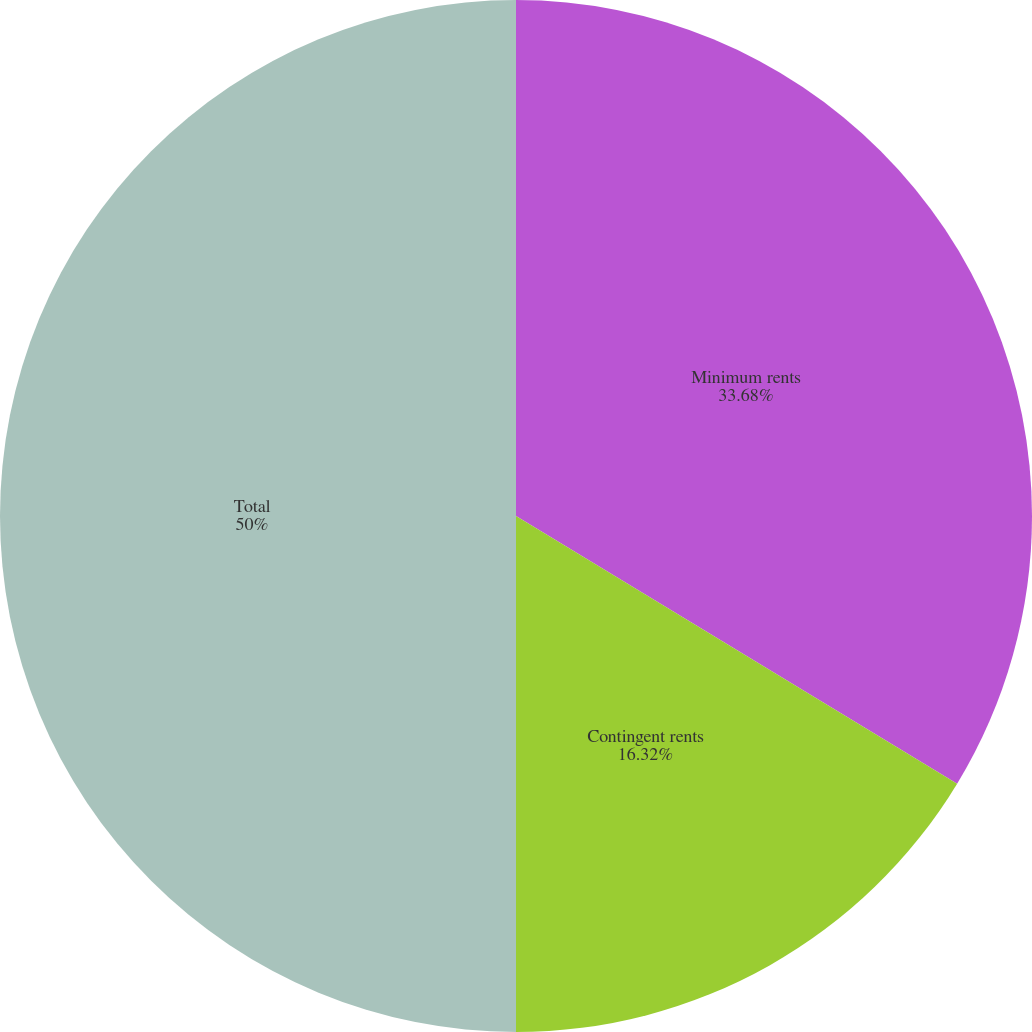Convert chart. <chart><loc_0><loc_0><loc_500><loc_500><pie_chart><fcel>Minimum rents<fcel>Contingent rents<fcel>Total<nl><fcel>33.68%<fcel>16.32%<fcel>50.0%<nl></chart> 